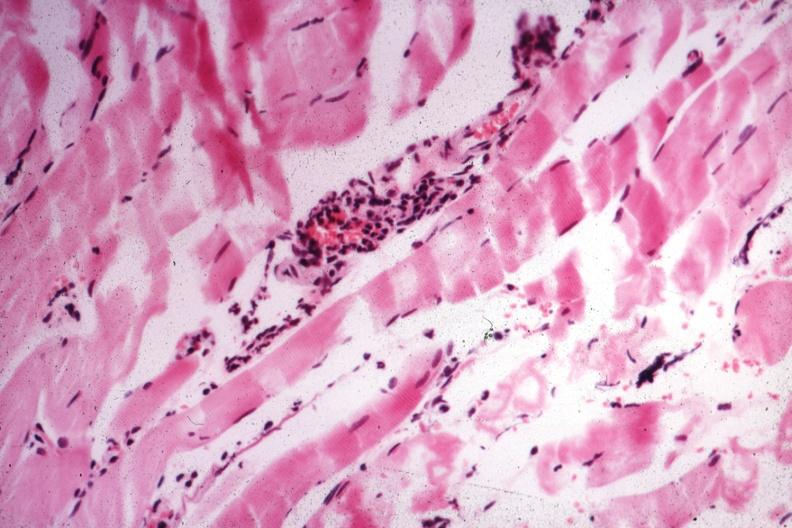s soft tissue present?
Answer the question using a single word or phrase. Yes 